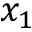<formula> <loc_0><loc_0><loc_500><loc_500>x _ { 1 }</formula> 